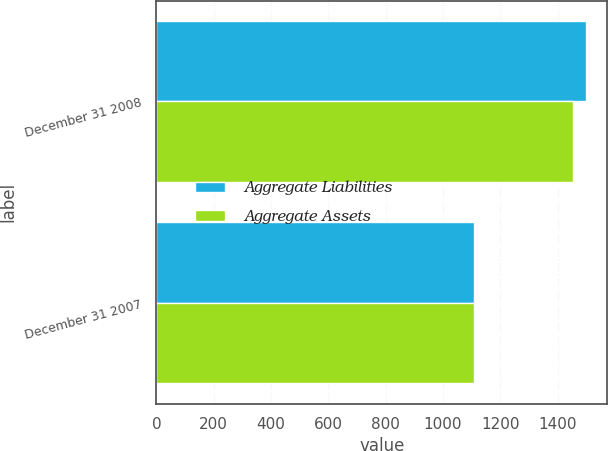<chart> <loc_0><loc_0><loc_500><loc_500><stacked_bar_chart><ecel><fcel>December 31 2008<fcel>December 31 2007<nl><fcel>Aggregate Liabilities<fcel>1499<fcel>1108<nl><fcel>Aggregate Assets<fcel>1455<fcel>1108<nl></chart> 